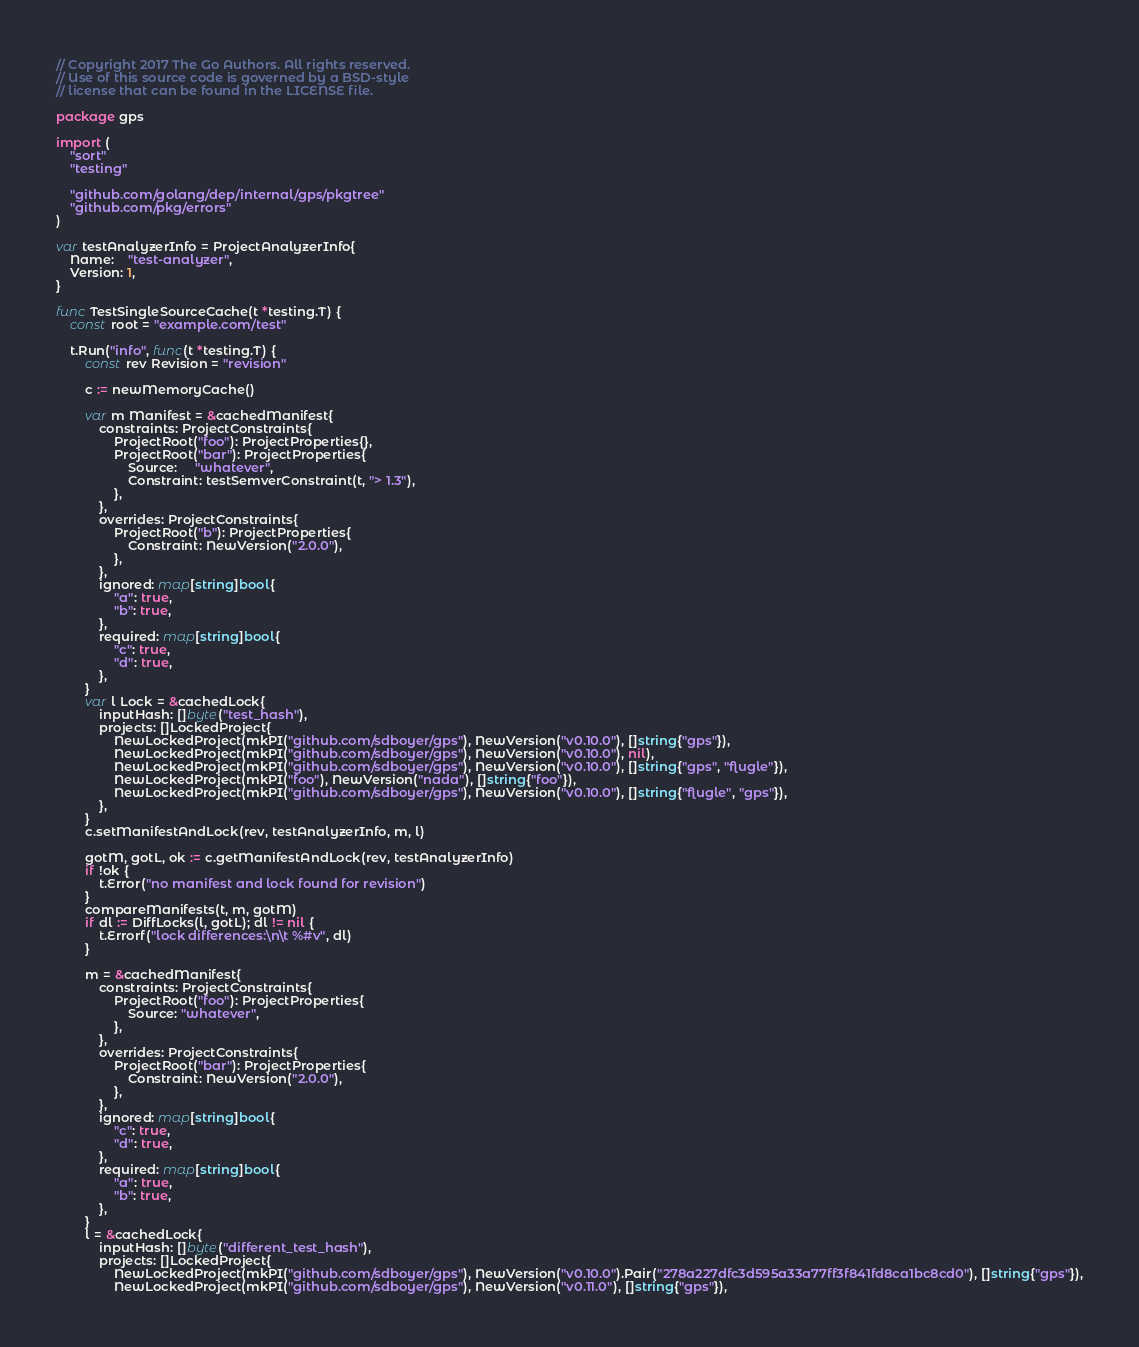<code> <loc_0><loc_0><loc_500><loc_500><_Go_>// Copyright 2017 The Go Authors. All rights reserved.
// Use of this source code is governed by a BSD-style
// license that can be found in the LICENSE file.

package gps

import (
	"sort"
	"testing"

	"github.com/golang/dep/internal/gps/pkgtree"
	"github.com/pkg/errors"
)

var testAnalyzerInfo = ProjectAnalyzerInfo{
	Name:    "test-analyzer",
	Version: 1,
}

func TestSingleSourceCache(t *testing.T) {
	const root = "example.com/test"

	t.Run("info", func(t *testing.T) {
		const rev Revision = "revision"

		c := newMemoryCache()

		var m Manifest = &cachedManifest{
			constraints: ProjectConstraints{
				ProjectRoot("foo"): ProjectProperties{},
				ProjectRoot("bar"): ProjectProperties{
					Source:     "whatever",
					Constraint: testSemverConstraint(t, "> 1.3"),
				},
			},
			overrides: ProjectConstraints{
				ProjectRoot("b"): ProjectProperties{
					Constraint: NewVersion("2.0.0"),
				},
			},
			ignored: map[string]bool{
				"a": true,
				"b": true,
			},
			required: map[string]bool{
				"c": true,
				"d": true,
			},
		}
		var l Lock = &cachedLock{
			inputHash: []byte("test_hash"),
			projects: []LockedProject{
				NewLockedProject(mkPI("github.com/sdboyer/gps"), NewVersion("v0.10.0"), []string{"gps"}),
				NewLockedProject(mkPI("github.com/sdboyer/gps"), NewVersion("v0.10.0"), nil),
				NewLockedProject(mkPI("github.com/sdboyer/gps"), NewVersion("v0.10.0"), []string{"gps", "flugle"}),
				NewLockedProject(mkPI("foo"), NewVersion("nada"), []string{"foo"}),
				NewLockedProject(mkPI("github.com/sdboyer/gps"), NewVersion("v0.10.0"), []string{"flugle", "gps"}),
			},
		}
		c.setManifestAndLock(rev, testAnalyzerInfo, m, l)

		gotM, gotL, ok := c.getManifestAndLock(rev, testAnalyzerInfo)
		if !ok {
			t.Error("no manifest and lock found for revision")
		}
		compareManifests(t, m, gotM)
		if dl := DiffLocks(l, gotL); dl != nil {
			t.Errorf("lock differences:\n\t %#v", dl)
		}

		m = &cachedManifest{
			constraints: ProjectConstraints{
				ProjectRoot("foo"): ProjectProperties{
					Source: "whatever",
				},
			},
			overrides: ProjectConstraints{
				ProjectRoot("bar"): ProjectProperties{
					Constraint: NewVersion("2.0.0"),
				},
			},
			ignored: map[string]bool{
				"c": true,
				"d": true,
			},
			required: map[string]bool{
				"a": true,
				"b": true,
			},
		}
		l = &cachedLock{
			inputHash: []byte("different_test_hash"),
			projects: []LockedProject{
				NewLockedProject(mkPI("github.com/sdboyer/gps"), NewVersion("v0.10.0").Pair("278a227dfc3d595a33a77ff3f841fd8ca1bc8cd0"), []string{"gps"}),
				NewLockedProject(mkPI("github.com/sdboyer/gps"), NewVersion("v0.11.0"), []string{"gps"}),</code> 